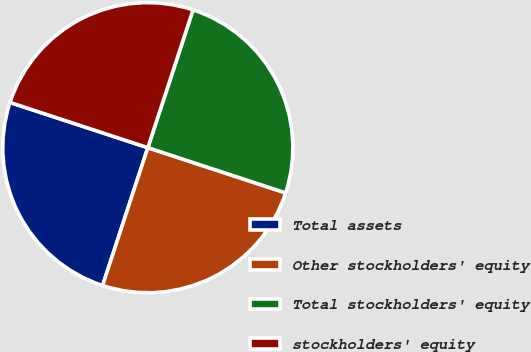Convert chart. <chart><loc_0><loc_0><loc_500><loc_500><pie_chart><fcel>Total assets<fcel>Other stockholders' equity<fcel>Total stockholders' equity<fcel>stockholders' equity<nl><fcel>25.0%<fcel>25.0%<fcel>25.0%<fcel>25.0%<nl></chart> 